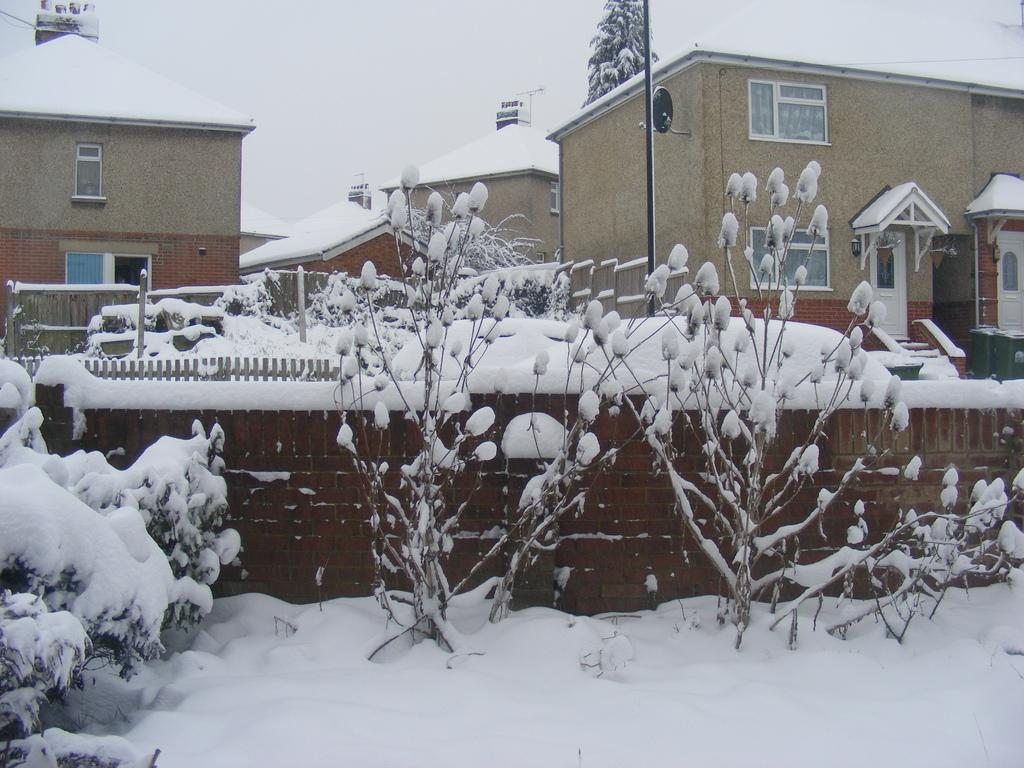What type of structures can be seen in the image? There are buildings in the image. What natural elements are present in the image? There are trees and plants in the image. What type of barrier can be seen in the image? There is a wooden fence in the image. How is the wooden fence affected by the weather in the image? The wooden fence is covered with snow in the image. What color is the crayon used to draw the mist in the image? There is no crayon or mist present in the image. 